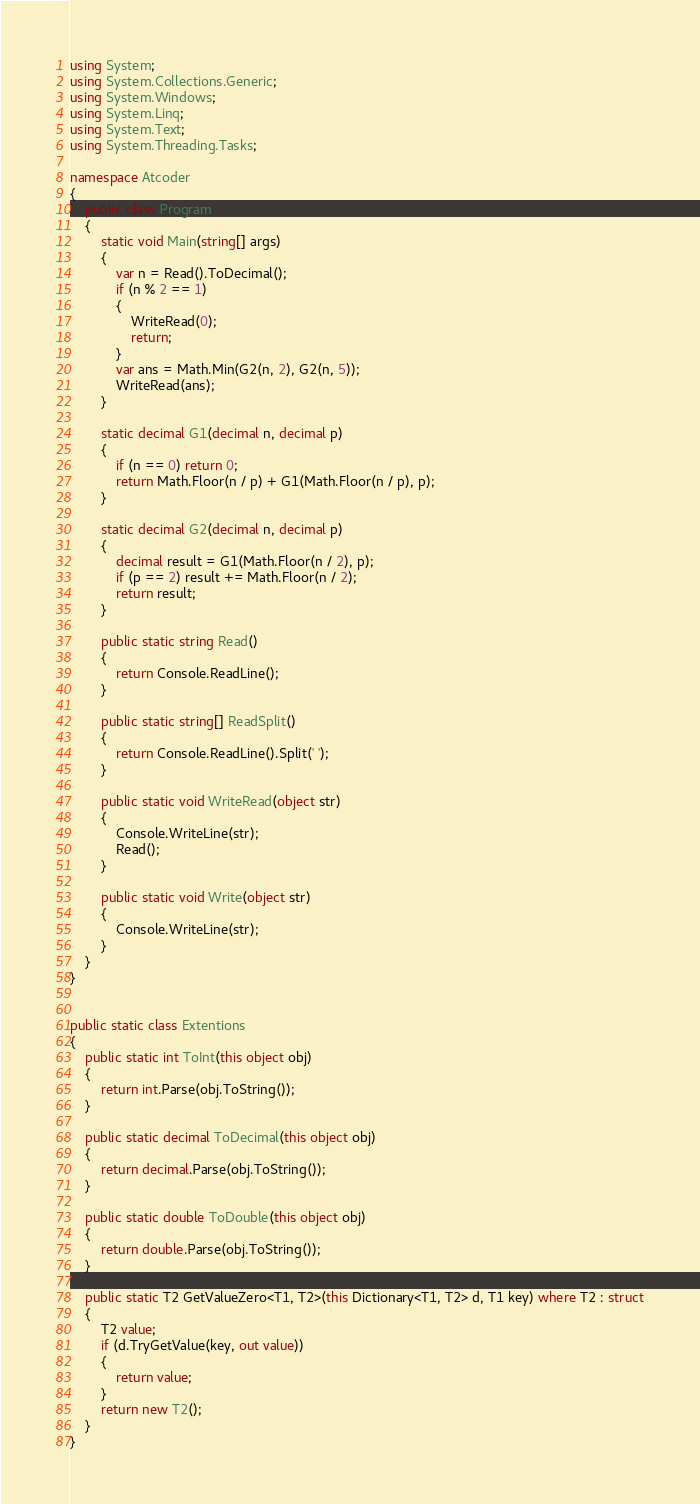<code> <loc_0><loc_0><loc_500><loc_500><_C#_>using System;
using System.Collections.Generic;
using System.Windows;
using System.Linq;
using System.Text;
using System.Threading.Tasks;

namespace Atcoder
{
    public class Program
    {
        static void Main(string[] args)
        {
            var n = Read().ToDecimal();
            if (n % 2 == 1)
            {
                WriteRead(0);
                return;
            }
            var ans = Math.Min(G2(n, 2), G2(n, 5));
            WriteRead(ans);
        }

        static decimal G1(decimal n, decimal p)
        {
            if (n == 0) return 0;
            return Math.Floor(n / p) + G1(Math.Floor(n / p), p);
        }

        static decimal G2(decimal n, decimal p)
        {
            decimal result = G1(Math.Floor(n / 2), p);
            if (p == 2) result += Math.Floor(n / 2);
            return result;
        }

        public static string Read()
        {
            return Console.ReadLine();
        }

        public static string[] ReadSplit()
        {
            return Console.ReadLine().Split(' ');
        }

        public static void WriteRead(object str)
        {
            Console.WriteLine(str);
            Read();
        }

        public static void Write(object str)
        {
            Console.WriteLine(str);
        }
    }
}


public static class Extentions
{
    public static int ToInt(this object obj)
    {
        return int.Parse(obj.ToString());
    }

    public static decimal ToDecimal(this object obj)
    {
        return decimal.Parse(obj.ToString());
    }

    public static double ToDouble(this object obj)
    {
        return double.Parse(obj.ToString());
    }

    public static T2 GetValueZero<T1, T2>(this Dictionary<T1, T2> d, T1 key) where T2 : struct
    {
        T2 value;
        if (d.TryGetValue(key, out value))
        {
            return value;
        }
        return new T2();
    }
}

</code> 